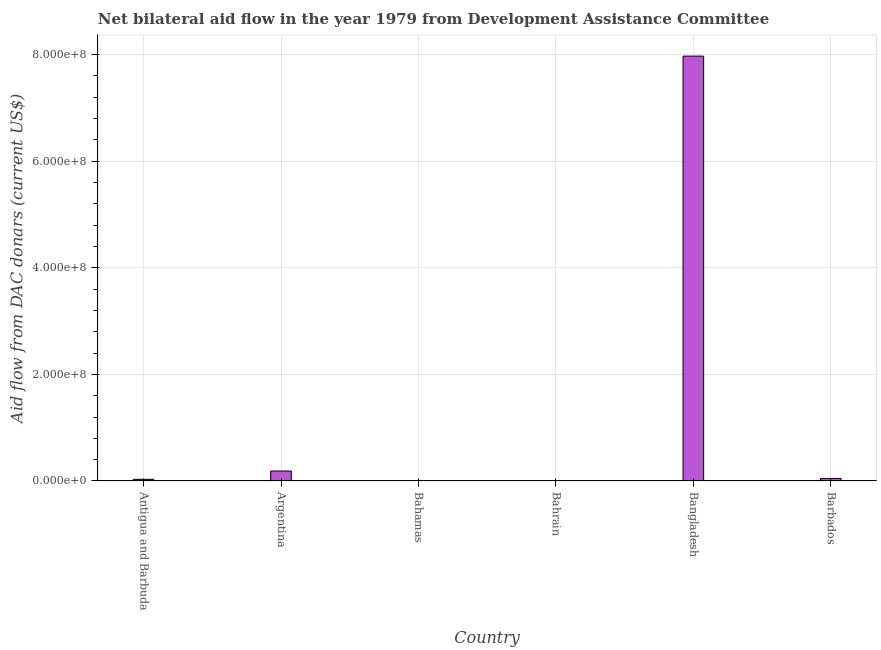What is the title of the graph?
Keep it short and to the point. Net bilateral aid flow in the year 1979 from Development Assistance Committee. What is the label or title of the Y-axis?
Make the answer very short. Aid flow from DAC donars (current US$). What is the net bilateral aid flows from dac donors in Barbados?
Keep it short and to the point. 4.78e+06. Across all countries, what is the maximum net bilateral aid flows from dac donors?
Provide a short and direct response. 7.97e+08. Across all countries, what is the minimum net bilateral aid flows from dac donors?
Your answer should be compact. 3.80e+05. In which country was the net bilateral aid flows from dac donors minimum?
Ensure brevity in your answer.  Bahamas. What is the sum of the net bilateral aid flows from dac donors?
Give a very brief answer. 8.25e+08. What is the difference between the net bilateral aid flows from dac donors in Antigua and Barbuda and Argentina?
Give a very brief answer. -1.56e+07. What is the average net bilateral aid flows from dac donors per country?
Your response must be concise. 1.37e+08. What is the median net bilateral aid flows from dac donors?
Your answer should be very brief. 3.93e+06. What is the ratio of the net bilateral aid flows from dac donors in Argentina to that in Barbados?
Make the answer very short. 3.91. Is the net bilateral aid flows from dac donors in Bahamas less than that in Bahrain?
Your answer should be very brief. Yes. Is the difference between the net bilateral aid flows from dac donors in Bahrain and Bangladesh greater than the difference between any two countries?
Ensure brevity in your answer.  No. What is the difference between the highest and the second highest net bilateral aid flows from dac donors?
Give a very brief answer. 7.78e+08. What is the difference between the highest and the lowest net bilateral aid flows from dac donors?
Offer a terse response. 7.97e+08. How many bars are there?
Make the answer very short. 6. Are all the bars in the graph horizontal?
Your response must be concise. No. What is the Aid flow from DAC donars (current US$) of Antigua and Barbuda?
Your answer should be very brief. 3.08e+06. What is the Aid flow from DAC donars (current US$) of Argentina?
Your response must be concise. 1.87e+07. What is the Aid flow from DAC donars (current US$) in Bahamas?
Give a very brief answer. 3.80e+05. What is the Aid flow from DAC donars (current US$) in Bahrain?
Ensure brevity in your answer.  8.20e+05. What is the Aid flow from DAC donars (current US$) of Bangladesh?
Make the answer very short. 7.97e+08. What is the Aid flow from DAC donars (current US$) in Barbados?
Give a very brief answer. 4.78e+06. What is the difference between the Aid flow from DAC donars (current US$) in Antigua and Barbuda and Argentina?
Make the answer very short. -1.56e+07. What is the difference between the Aid flow from DAC donars (current US$) in Antigua and Barbuda and Bahamas?
Offer a terse response. 2.70e+06. What is the difference between the Aid flow from DAC donars (current US$) in Antigua and Barbuda and Bahrain?
Offer a terse response. 2.26e+06. What is the difference between the Aid flow from DAC donars (current US$) in Antigua and Barbuda and Bangladesh?
Provide a short and direct response. -7.94e+08. What is the difference between the Aid flow from DAC donars (current US$) in Antigua and Barbuda and Barbados?
Your answer should be compact. -1.70e+06. What is the difference between the Aid flow from DAC donars (current US$) in Argentina and Bahamas?
Keep it short and to the point. 1.83e+07. What is the difference between the Aid flow from DAC donars (current US$) in Argentina and Bahrain?
Offer a very short reply. 1.79e+07. What is the difference between the Aid flow from DAC donars (current US$) in Argentina and Bangladesh?
Your response must be concise. -7.78e+08. What is the difference between the Aid flow from DAC donars (current US$) in Argentina and Barbados?
Ensure brevity in your answer.  1.39e+07. What is the difference between the Aid flow from DAC donars (current US$) in Bahamas and Bahrain?
Make the answer very short. -4.40e+05. What is the difference between the Aid flow from DAC donars (current US$) in Bahamas and Bangladesh?
Provide a succinct answer. -7.97e+08. What is the difference between the Aid flow from DAC donars (current US$) in Bahamas and Barbados?
Your answer should be very brief. -4.40e+06. What is the difference between the Aid flow from DAC donars (current US$) in Bahrain and Bangladesh?
Your answer should be compact. -7.96e+08. What is the difference between the Aid flow from DAC donars (current US$) in Bahrain and Barbados?
Ensure brevity in your answer.  -3.96e+06. What is the difference between the Aid flow from DAC donars (current US$) in Bangladesh and Barbados?
Your response must be concise. 7.92e+08. What is the ratio of the Aid flow from DAC donars (current US$) in Antigua and Barbuda to that in Argentina?
Your response must be concise. 0.17. What is the ratio of the Aid flow from DAC donars (current US$) in Antigua and Barbuda to that in Bahamas?
Your answer should be compact. 8.11. What is the ratio of the Aid flow from DAC donars (current US$) in Antigua and Barbuda to that in Bahrain?
Offer a terse response. 3.76. What is the ratio of the Aid flow from DAC donars (current US$) in Antigua and Barbuda to that in Bangladesh?
Give a very brief answer. 0. What is the ratio of the Aid flow from DAC donars (current US$) in Antigua and Barbuda to that in Barbados?
Your answer should be compact. 0.64. What is the ratio of the Aid flow from DAC donars (current US$) in Argentina to that in Bahamas?
Keep it short and to the point. 49.18. What is the ratio of the Aid flow from DAC donars (current US$) in Argentina to that in Bahrain?
Your answer should be very brief. 22.79. What is the ratio of the Aid flow from DAC donars (current US$) in Argentina to that in Bangladesh?
Provide a short and direct response. 0.02. What is the ratio of the Aid flow from DAC donars (current US$) in Argentina to that in Barbados?
Your response must be concise. 3.91. What is the ratio of the Aid flow from DAC donars (current US$) in Bahamas to that in Bahrain?
Your response must be concise. 0.46. What is the ratio of the Aid flow from DAC donars (current US$) in Bahamas to that in Bangladesh?
Make the answer very short. 0. What is the ratio of the Aid flow from DAC donars (current US$) in Bahamas to that in Barbados?
Keep it short and to the point. 0.08. What is the ratio of the Aid flow from DAC donars (current US$) in Bahrain to that in Bangladesh?
Your answer should be compact. 0. What is the ratio of the Aid flow from DAC donars (current US$) in Bahrain to that in Barbados?
Ensure brevity in your answer.  0.17. What is the ratio of the Aid flow from DAC donars (current US$) in Bangladesh to that in Barbados?
Your response must be concise. 166.75. 